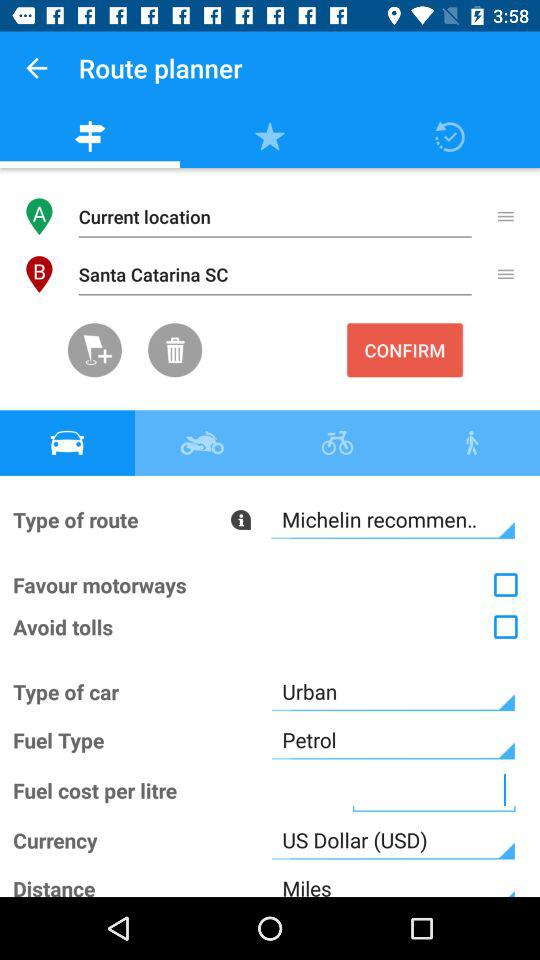Which type of currency is selected in the application? The selected type of currency is the US dollar (USD). 